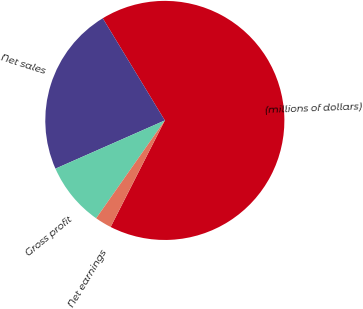Convert chart. <chart><loc_0><loc_0><loc_500><loc_500><pie_chart><fcel>(millions of dollars)<fcel>Net sales<fcel>Gross profit<fcel>Net earnings<nl><fcel>66.18%<fcel>22.92%<fcel>8.65%<fcel>2.25%<nl></chart> 